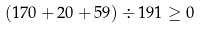Convert formula to latex. <formula><loc_0><loc_0><loc_500><loc_500>( 1 7 0 + 2 0 + 5 9 ) \div 1 9 1 \geq 0</formula> 